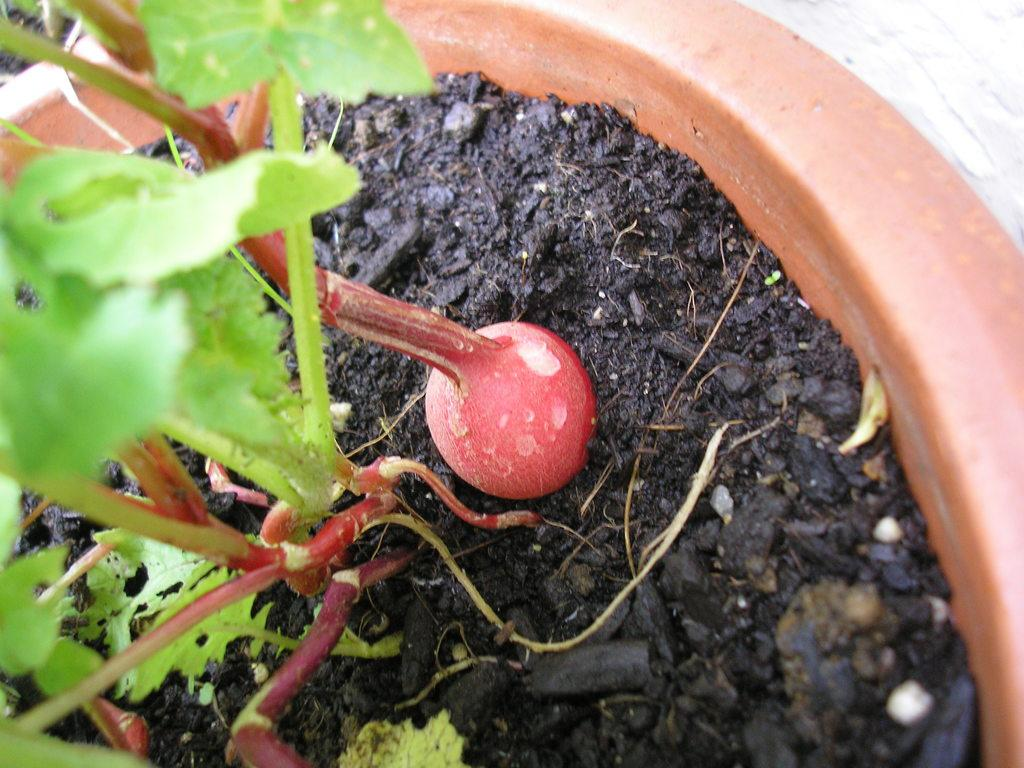What object is present in the image that is typically used for holding plants? There is a plant pot in the image. What is inside the plant pot? There is a plant in the plant pot. What type of produce can be seen growing in the plant pot? There is no produce visible in the image; it only shows a plant in the plant pot. How many appliances are present in the image? There are no appliances present in the image; it only shows a plant pot with a plant. 